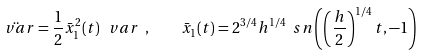Convert formula to latex. <formula><loc_0><loc_0><loc_500><loc_500>\ddot { \ v a r } = \frac { 1 } { 2 } \bar { x } ^ { 2 } _ { 1 } ( t ) \, \ v a r \ , \quad \bar { x } _ { 1 } ( t ) = 2 ^ { 3 / 4 } h ^ { 1 / 4 } \ s n \left ( \left ( \frac { h } { 2 } \right ) ^ { 1 / 4 } t , - 1 \right )</formula> 